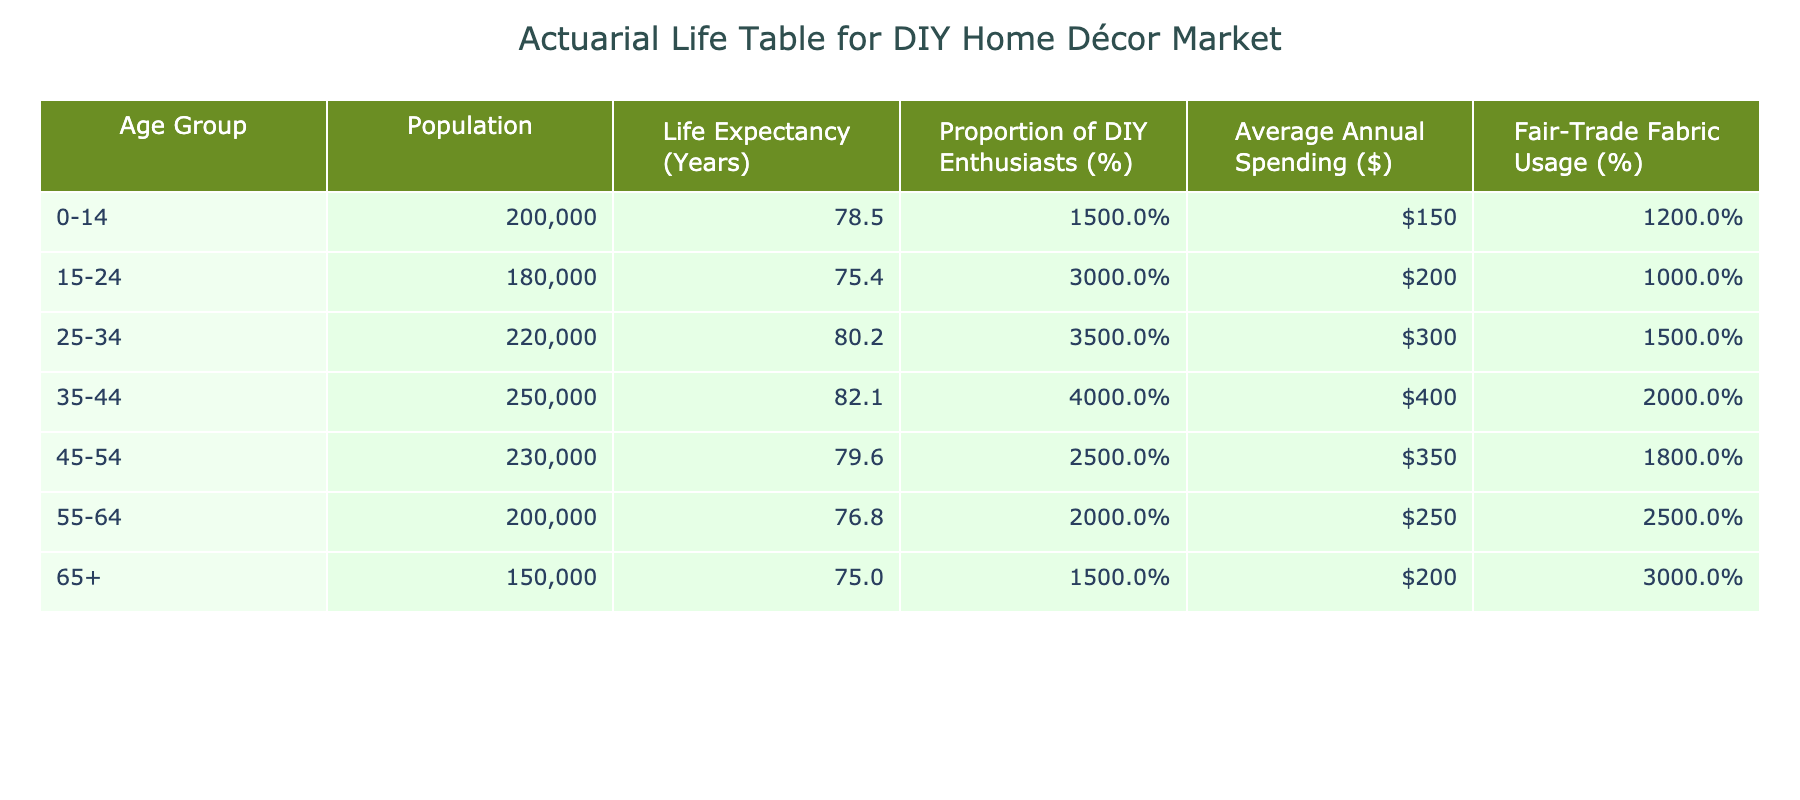What is the life expectancy for the age group 55-64? The life expectancy for the age group 55-64 is listed directly in the table under the column "Life Expectancy (Years)." It shows 76.8 years for this age group.
Answer: 76.8 Which age group has the highest proportion of DIY enthusiasts? By reviewing the "Proportion of DIY Enthusiasts" column, the age group 35-44 has the highest percentage at 40%.
Answer: 35-44 What is the average annual spending on home décor products for the age group 45-54? Referring to the "Average Annual Spending on Home Décor Products ($)" column, the figure for the age group 45-54 is $350.
Answer: 350 Is the fair-trade fabric usage rate for the age group 0-14 higher than that for the age group 45-54? Comparing the "Fair-Trade Fabric Usage Rate (%)" for both groups, 0-14 has a rate of 12%, while 45-54 has a rate of 18%. Since 12% is less than 18%, the statement is false.
Answer: No What is the total population of the age groups 25-34 and 35-44 combined? Summing the populations of both age groups: 220,000 (for 25-34) + 250,000 (for 35-44) equals 470,000. Therefore, the total population of these two age groups combined is 470,000.
Answer: 470,000 Which age group spends the least on average on home décor products? Looking at the "Average Annual Spending on Home Décor Products ($)" column, the age group 55-64 has the least amount of $250.
Answer: 55-64 If you average the life expectancy of all the age groups, what would be the result? To find the average life expectancy, we sum the life expectancies of all age groups: (78.5 + 75.4 + 80.2 + 82.1 + 79.6 + 76.8 + 75.0) / 7 equals approximately 77.6 years.
Answer: 77.6 Do age groups above 55 typically have a higher fair-trade fabric usage rate compared to younger age groups? Examining the fair-trade fabric usage rates: for age groups 55-64 (25%) and 65+ (30%), while younger groups (0-14 at 12%, 15-24 at 10%, 25-34 at 15%, 35-44 at 20%, and 45-54 at 18%) all have lower rates than both older groups. This indicates that older groups do have higher rates on average.
Answer: Yes 